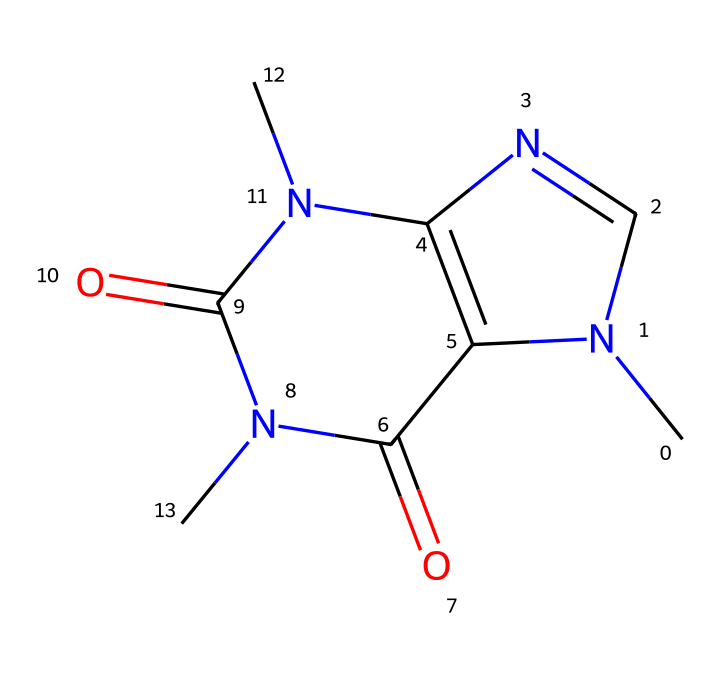What is the molecular formula of caffeine? To find the molecular formula, we can identify the types and counts of atoms present in the SMILES representation. Analyzing the structure, we find that caffeine consists of 8 carbon atoms (C), 10 hydrogen atoms (H), 4 nitrogen atoms (N), and 2 oxygen atoms (O). Combining these gives us C8H10N4O2.
Answer: C8H10N4O2 How many rings are present in the structure of caffeine? Looking at the SMILES representation, we can identify the cyclic parts of the molecule. There are two numbers indicating ring closures (1 and 2), signifying two interconnected cyclic structures. Thus, there are two rings in total in the caffeine structure.
Answer: 2 Is caffeine classified as a stimulant or depressant? Caffeine, according to its pharmacological properties, is known to act primarily as a stimulant on the central nervous system. This classification is widely recognized due to its common use to increase alertness and reduce fatigue.
Answer: stimulant How many nitrogen atoms are present in caffeine? By examining the chemical structure, we can explicitly count the nitrogen atoms denoted in the formula. There are four nitrogen atoms present in the caffeine structure, which are essential for its biochemical activity.
Answer: 4 What type of compound is caffeine categorized under? Caffeine is a member of a specific class of compounds known as alkaloids. The presence of multiple nitrogen atoms and its natural occurrence in plants like coffee and tea reinforces its classification as an alkaloid.
Answer: alkaloid Which feature of caffeine contributes to its solubility in water? The presence of polar functional groups, particularly the nitrogen and oxygen atoms, facilitates hydrogen bonding with water molecules. This contributes significantly to caffeine's solubility in water, which is a characteristic property of many small polar molecules.
Answer: polar functional groups What is the primary biological effect of caffeine on the human body? Caffeine predominantly functions as an adenosine receptor antagonist, blocking the action of adenosine and leading to increased neuronal firing and release of neurotransmitters like dopamine and norepinephrine. These effects account for heightened alertness and improved mood.
Answer: increased alertness 